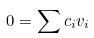<formula> <loc_0><loc_0><loc_500><loc_500>0 = \sum c _ { i } v _ { i }</formula> 